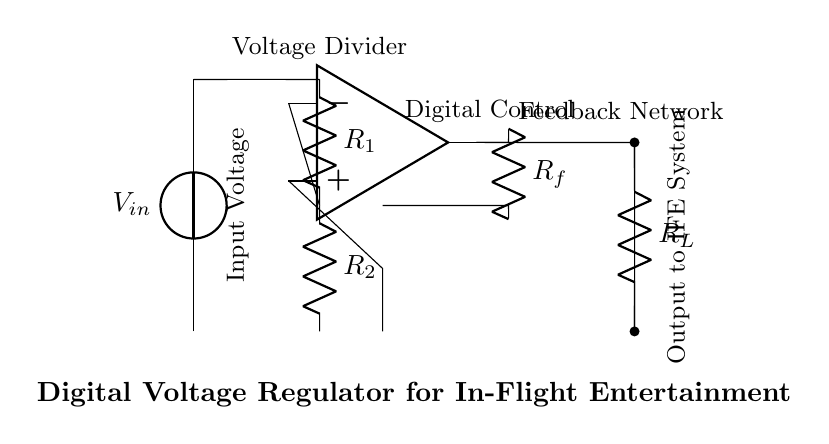What type of circuit is depicted? The circuit drawn is a digital voltage regulator specifically designed for in-flight entertainment systems. This is identifiable by the presence of an operational amplifier, feedback network, and the components specifying voltage regulation.
Answer: Digital Voltage Regulator What is the function of the operational amplifier? The operational amplifier in the circuit acts as a comparator that regulates the output voltage by comparing the input reference voltage from the voltage divider to the feedback voltage. It adjusts the output accordingly to maintain a stable voltage.
Answer: Regulation What does the feedback loop consist of? The feedback loop consists of a resistor labeled as Rf, which connects the output of the operational amplifier back to its inverting input. This feedback is essential for stabilizing the output voltage by comparing it to the desired reference voltage.
Answer: Rf What are R1 and R2 used for in this circuit? R1 and R2 form a voltage divider, which provides a reference voltage to the inverting input of the operational amplifier. This reference voltage is crucial for determining the target output voltage of the regulator.
Answer: Voltage Divider What is the expected output signal destination? The output of the circuit is connected to a load resistor labeled Rl, which signifies that the voltage regulator is supplying power to the in-flight entertainment system.
Answer: IFE System How does the feedback network affect the output? The feedback network alters the operational amplifier's output based on the difference between the output voltage and the reference voltage, allowing the circuit to adjust and stabilize the output despite changes in load or input voltage.
Answer: Stabilization 